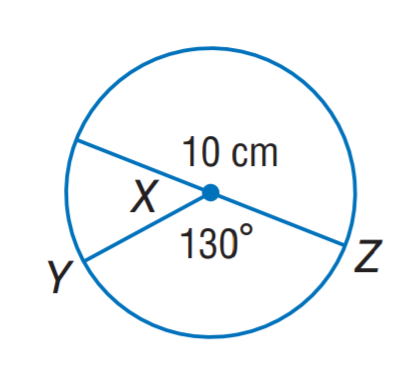Answer the mathemtical geometry problem and directly provide the correct option letter.
Question: Find the length of \widehat Z Y. Round to the nearest hundredth.
Choices: A: 10.23 B: 11.34 C: 12.67 D: 15.16 B 